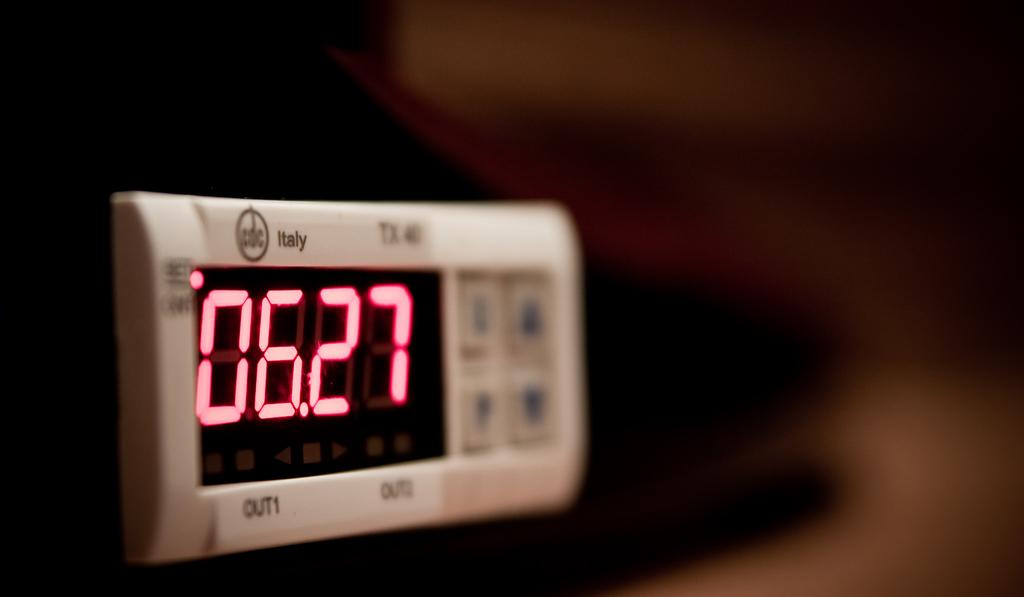<image>
Create a compact narrative representing the image presented. an Italy beige digital timer clock with pink numbers 06.27 